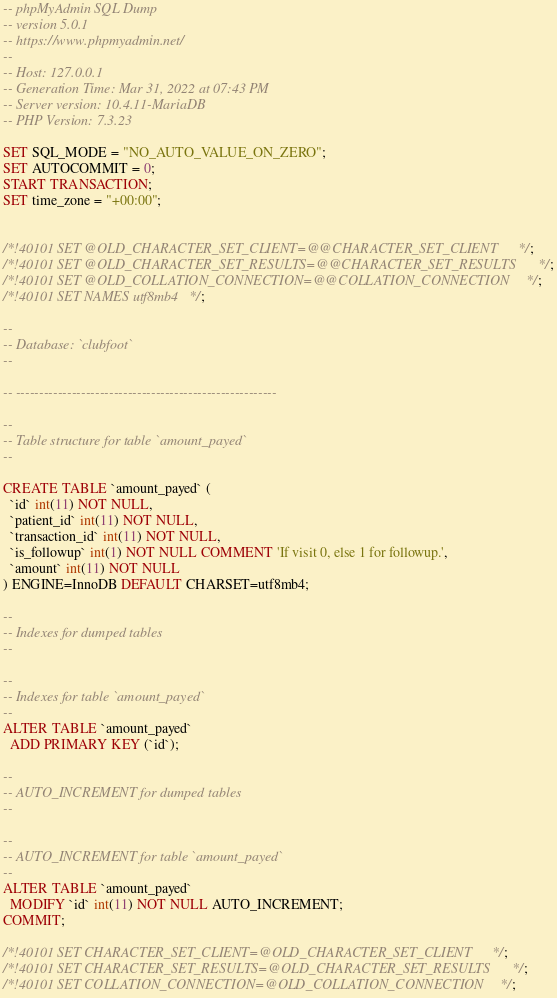Convert code to text. <code><loc_0><loc_0><loc_500><loc_500><_SQL_>-- phpMyAdmin SQL Dump
-- version 5.0.1
-- https://www.phpmyadmin.net/
--
-- Host: 127.0.0.1
-- Generation Time: Mar 31, 2022 at 07:43 PM
-- Server version: 10.4.11-MariaDB
-- PHP Version: 7.3.23

SET SQL_MODE = "NO_AUTO_VALUE_ON_ZERO";
SET AUTOCOMMIT = 0;
START TRANSACTION;
SET time_zone = "+00:00";


/*!40101 SET @OLD_CHARACTER_SET_CLIENT=@@CHARACTER_SET_CLIENT */;
/*!40101 SET @OLD_CHARACTER_SET_RESULTS=@@CHARACTER_SET_RESULTS */;
/*!40101 SET @OLD_COLLATION_CONNECTION=@@COLLATION_CONNECTION */;
/*!40101 SET NAMES utf8mb4 */;

--
-- Database: `clubfoot`
--

-- --------------------------------------------------------

--
-- Table structure for table `amount_payed`
--

CREATE TABLE `amount_payed` (
  `id` int(11) NOT NULL,
  `patient_id` int(11) NOT NULL,
  `transaction_id` int(11) NOT NULL,
  `is_followup` int(1) NOT NULL COMMENT 'If visit 0, else 1 for followup.',
  `amount` int(11) NOT NULL
) ENGINE=InnoDB DEFAULT CHARSET=utf8mb4;

--
-- Indexes for dumped tables
--

--
-- Indexes for table `amount_payed`
--
ALTER TABLE `amount_payed`
  ADD PRIMARY KEY (`id`);

--
-- AUTO_INCREMENT for dumped tables
--

--
-- AUTO_INCREMENT for table `amount_payed`
--
ALTER TABLE `amount_payed`
  MODIFY `id` int(11) NOT NULL AUTO_INCREMENT;
COMMIT;

/*!40101 SET CHARACTER_SET_CLIENT=@OLD_CHARACTER_SET_CLIENT */;
/*!40101 SET CHARACTER_SET_RESULTS=@OLD_CHARACTER_SET_RESULTS */;
/*!40101 SET COLLATION_CONNECTION=@OLD_COLLATION_CONNECTION */;
</code> 